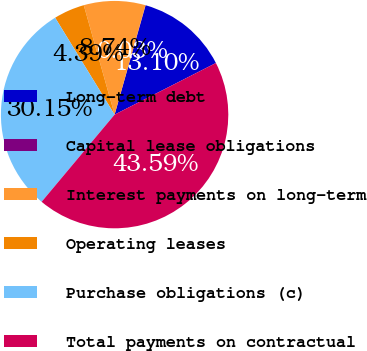Convert chart to OTSL. <chart><loc_0><loc_0><loc_500><loc_500><pie_chart><fcel>Long-term debt<fcel>Capital lease obligations<fcel>Interest payments on long-term<fcel>Operating leases<fcel>Purchase obligations (c)<fcel>Total payments on contractual<nl><fcel>13.1%<fcel>0.03%<fcel>8.74%<fcel>4.39%<fcel>30.15%<fcel>43.59%<nl></chart> 